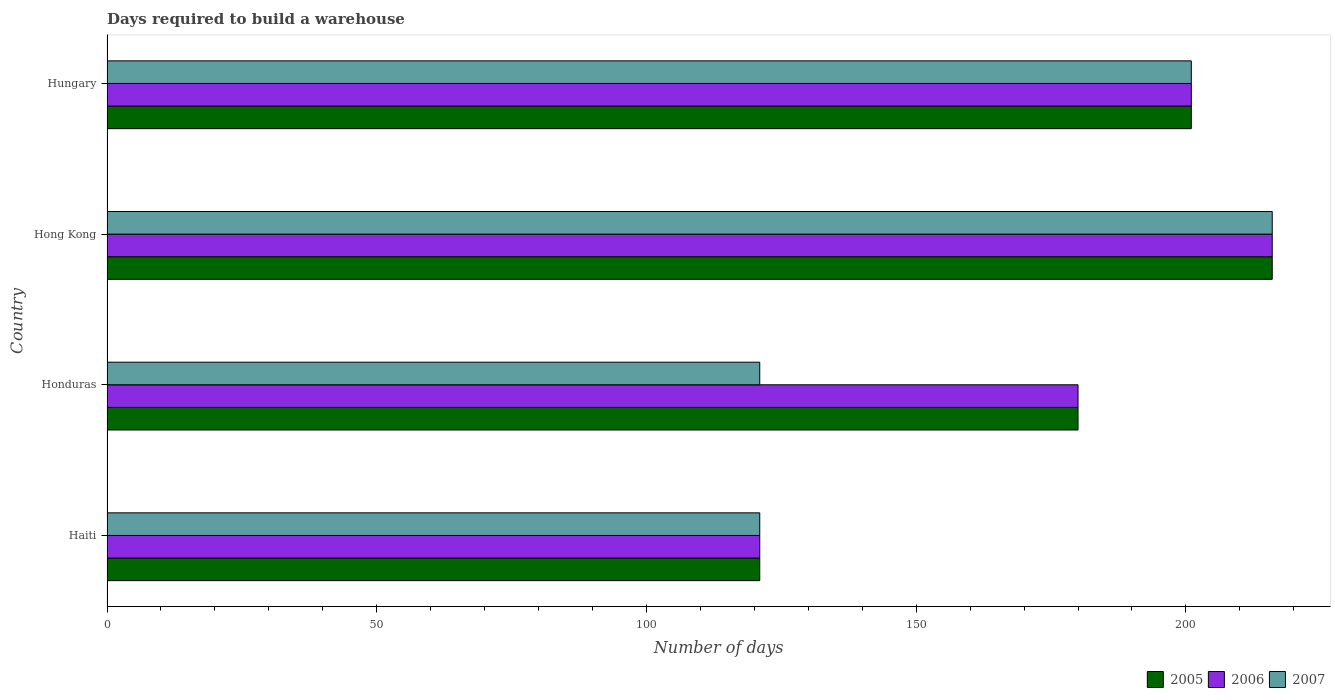How many groups of bars are there?
Make the answer very short. 4. How many bars are there on the 2nd tick from the top?
Give a very brief answer. 3. How many bars are there on the 2nd tick from the bottom?
Ensure brevity in your answer.  3. What is the label of the 4th group of bars from the top?
Keep it short and to the point. Haiti. What is the days required to build a warehouse in in 2005 in Haiti?
Keep it short and to the point. 121. Across all countries, what is the maximum days required to build a warehouse in in 2007?
Keep it short and to the point. 216. Across all countries, what is the minimum days required to build a warehouse in in 2007?
Keep it short and to the point. 121. In which country was the days required to build a warehouse in in 2005 maximum?
Give a very brief answer. Hong Kong. In which country was the days required to build a warehouse in in 2006 minimum?
Make the answer very short. Haiti. What is the total days required to build a warehouse in in 2006 in the graph?
Provide a succinct answer. 718. What is the difference between the days required to build a warehouse in in 2007 in Honduras and that in Hungary?
Your answer should be compact. -80. What is the difference between the days required to build a warehouse in in 2007 in Honduras and the days required to build a warehouse in in 2006 in Hong Kong?
Ensure brevity in your answer.  -95. What is the average days required to build a warehouse in in 2007 per country?
Your answer should be compact. 164.75. What is the difference between the days required to build a warehouse in in 2006 and days required to build a warehouse in in 2007 in Hungary?
Provide a short and direct response. 0. In how many countries, is the days required to build a warehouse in in 2005 greater than 100 days?
Your response must be concise. 4. What is the ratio of the days required to build a warehouse in in 2005 in Hong Kong to that in Hungary?
Make the answer very short. 1.07. What does the 1st bar from the bottom in Haiti represents?
Your response must be concise. 2005. Is it the case that in every country, the sum of the days required to build a warehouse in in 2006 and days required to build a warehouse in in 2005 is greater than the days required to build a warehouse in in 2007?
Make the answer very short. Yes. How many bars are there?
Offer a terse response. 12. How many countries are there in the graph?
Ensure brevity in your answer.  4. Are the values on the major ticks of X-axis written in scientific E-notation?
Give a very brief answer. No. Does the graph contain any zero values?
Your answer should be compact. No. Does the graph contain grids?
Make the answer very short. No. How are the legend labels stacked?
Provide a short and direct response. Horizontal. What is the title of the graph?
Make the answer very short. Days required to build a warehouse. What is the label or title of the X-axis?
Offer a very short reply. Number of days. What is the Number of days of 2005 in Haiti?
Offer a terse response. 121. What is the Number of days of 2006 in Haiti?
Keep it short and to the point. 121. What is the Number of days in 2007 in Haiti?
Your response must be concise. 121. What is the Number of days in 2005 in Honduras?
Offer a terse response. 180. What is the Number of days of 2006 in Honduras?
Ensure brevity in your answer.  180. What is the Number of days in 2007 in Honduras?
Keep it short and to the point. 121. What is the Number of days in 2005 in Hong Kong?
Keep it short and to the point. 216. What is the Number of days in 2006 in Hong Kong?
Provide a succinct answer. 216. What is the Number of days of 2007 in Hong Kong?
Ensure brevity in your answer.  216. What is the Number of days in 2005 in Hungary?
Keep it short and to the point. 201. What is the Number of days of 2006 in Hungary?
Your response must be concise. 201. What is the Number of days in 2007 in Hungary?
Your answer should be very brief. 201. Across all countries, what is the maximum Number of days of 2005?
Give a very brief answer. 216. Across all countries, what is the maximum Number of days in 2006?
Make the answer very short. 216. Across all countries, what is the maximum Number of days in 2007?
Ensure brevity in your answer.  216. Across all countries, what is the minimum Number of days of 2005?
Give a very brief answer. 121. Across all countries, what is the minimum Number of days in 2006?
Provide a short and direct response. 121. Across all countries, what is the minimum Number of days in 2007?
Provide a succinct answer. 121. What is the total Number of days of 2005 in the graph?
Keep it short and to the point. 718. What is the total Number of days in 2006 in the graph?
Provide a short and direct response. 718. What is the total Number of days of 2007 in the graph?
Offer a very short reply. 659. What is the difference between the Number of days of 2005 in Haiti and that in Honduras?
Provide a succinct answer. -59. What is the difference between the Number of days of 2006 in Haiti and that in Honduras?
Provide a short and direct response. -59. What is the difference between the Number of days in 2007 in Haiti and that in Honduras?
Offer a very short reply. 0. What is the difference between the Number of days of 2005 in Haiti and that in Hong Kong?
Your answer should be very brief. -95. What is the difference between the Number of days in 2006 in Haiti and that in Hong Kong?
Keep it short and to the point. -95. What is the difference between the Number of days of 2007 in Haiti and that in Hong Kong?
Offer a terse response. -95. What is the difference between the Number of days of 2005 in Haiti and that in Hungary?
Ensure brevity in your answer.  -80. What is the difference between the Number of days in 2006 in Haiti and that in Hungary?
Offer a terse response. -80. What is the difference between the Number of days of 2007 in Haiti and that in Hungary?
Offer a terse response. -80. What is the difference between the Number of days of 2005 in Honduras and that in Hong Kong?
Give a very brief answer. -36. What is the difference between the Number of days in 2006 in Honduras and that in Hong Kong?
Keep it short and to the point. -36. What is the difference between the Number of days of 2007 in Honduras and that in Hong Kong?
Give a very brief answer. -95. What is the difference between the Number of days of 2006 in Honduras and that in Hungary?
Provide a succinct answer. -21. What is the difference between the Number of days of 2007 in Honduras and that in Hungary?
Offer a very short reply. -80. What is the difference between the Number of days in 2005 in Hong Kong and that in Hungary?
Offer a very short reply. 15. What is the difference between the Number of days in 2007 in Hong Kong and that in Hungary?
Your answer should be very brief. 15. What is the difference between the Number of days of 2005 in Haiti and the Number of days of 2006 in Honduras?
Give a very brief answer. -59. What is the difference between the Number of days in 2005 in Haiti and the Number of days in 2006 in Hong Kong?
Provide a short and direct response. -95. What is the difference between the Number of days of 2005 in Haiti and the Number of days of 2007 in Hong Kong?
Provide a short and direct response. -95. What is the difference between the Number of days of 2006 in Haiti and the Number of days of 2007 in Hong Kong?
Keep it short and to the point. -95. What is the difference between the Number of days of 2005 in Haiti and the Number of days of 2006 in Hungary?
Your response must be concise. -80. What is the difference between the Number of days in 2005 in Haiti and the Number of days in 2007 in Hungary?
Provide a short and direct response. -80. What is the difference between the Number of days of 2006 in Haiti and the Number of days of 2007 in Hungary?
Keep it short and to the point. -80. What is the difference between the Number of days of 2005 in Honduras and the Number of days of 2006 in Hong Kong?
Make the answer very short. -36. What is the difference between the Number of days of 2005 in Honduras and the Number of days of 2007 in Hong Kong?
Give a very brief answer. -36. What is the difference between the Number of days of 2006 in Honduras and the Number of days of 2007 in Hong Kong?
Your response must be concise. -36. What is the difference between the Number of days of 2006 in Honduras and the Number of days of 2007 in Hungary?
Give a very brief answer. -21. What is the difference between the Number of days in 2005 in Hong Kong and the Number of days in 2006 in Hungary?
Make the answer very short. 15. What is the difference between the Number of days in 2006 in Hong Kong and the Number of days in 2007 in Hungary?
Provide a succinct answer. 15. What is the average Number of days of 2005 per country?
Make the answer very short. 179.5. What is the average Number of days in 2006 per country?
Provide a succinct answer. 179.5. What is the average Number of days of 2007 per country?
Your answer should be compact. 164.75. What is the difference between the Number of days in 2006 and Number of days in 2007 in Haiti?
Provide a succinct answer. 0. What is the difference between the Number of days in 2005 and Number of days in 2007 in Honduras?
Offer a terse response. 59. What is the difference between the Number of days in 2006 and Number of days in 2007 in Honduras?
Keep it short and to the point. 59. What is the difference between the Number of days of 2006 and Number of days of 2007 in Hong Kong?
Offer a very short reply. 0. What is the difference between the Number of days in 2006 and Number of days in 2007 in Hungary?
Ensure brevity in your answer.  0. What is the ratio of the Number of days of 2005 in Haiti to that in Honduras?
Provide a short and direct response. 0.67. What is the ratio of the Number of days of 2006 in Haiti to that in Honduras?
Your response must be concise. 0.67. What is the ratio of the Number of days in 2007 in Haiti to that in Honduras?
Provide a succinct answer. 1. What is the ratio of the Number of days of 2005 in Haiti to that in Hong Kong?
Offer a very short reply. 0.56. What is the ratio of the Number of days in 2006 in Haiti to that in Hong Kong?
Ensure brevity in your answer.  0.56. What is the ratio of the Number of days in 2007 in Haiti to that in Hong Kong?
Your answer should be compact. 0.56. What is the ratio of the Number of days in 2005 in Haiti to that in Hungary?
Provide a succinct answer. 0.6. What is the ratio of the Number of days of 2006 in Haiti to that in Hungary?
Your response must be concise. 0.6. What is the ratio of the Number of days in 2007 in Haiti to that in Hungary?
Keep it short and to the point. 0.6. What is the ratio of the Number of days of 2005 in Honduras to that in Hong Kong?
Give a very brief answer. 0.83. What is the ratio of the Number of days in 2006 in Honduras to that in Hong Kong?
Ensure brevity in your answer.  0.83. What is the ratio of the Number of days of 2007 in Honduras to that in Hong Kong?
Provide a succinct answer. 0.56. What is the ratio of the Number of days of 2005 in Honduras to that in Hungary?
Your answer should be compact. 0.9. What is the ratio of the Number of days in 2006 in Honduras to that in Hungary?
Offer a very short reply. 0.9. What is the ratio of the Number of days of 2007 in Honduras to that in Hungary?
Your answer should be very brief. 0.6. What is the ratio of the Number of days in 2005 in Hong Kong to that in Hungary?
Provide a succinct answer. 1.07. What is the ratio of the Number of days of 2006 in Hong Kong to that in Hungary?
Make the answer very short. 1.07. What is the ratio of the Number of days of 2007 in Hong Kong to that in Hungary?
Provide a short and direct response. 1.07. What is the difference between the highest and the second highest Number of days of 2005?
Offer a terse response. 15. What is the difference between the highest and the second highest Number of days in 2006?
Offer a terse response. 15. What is the difference between the highest and the second highest Number of days in 2007?
Provide a short and direct response. 15. What is the difference between the highest and the lowest Number of days in 2006?
Provide a succinct answer. 95. 